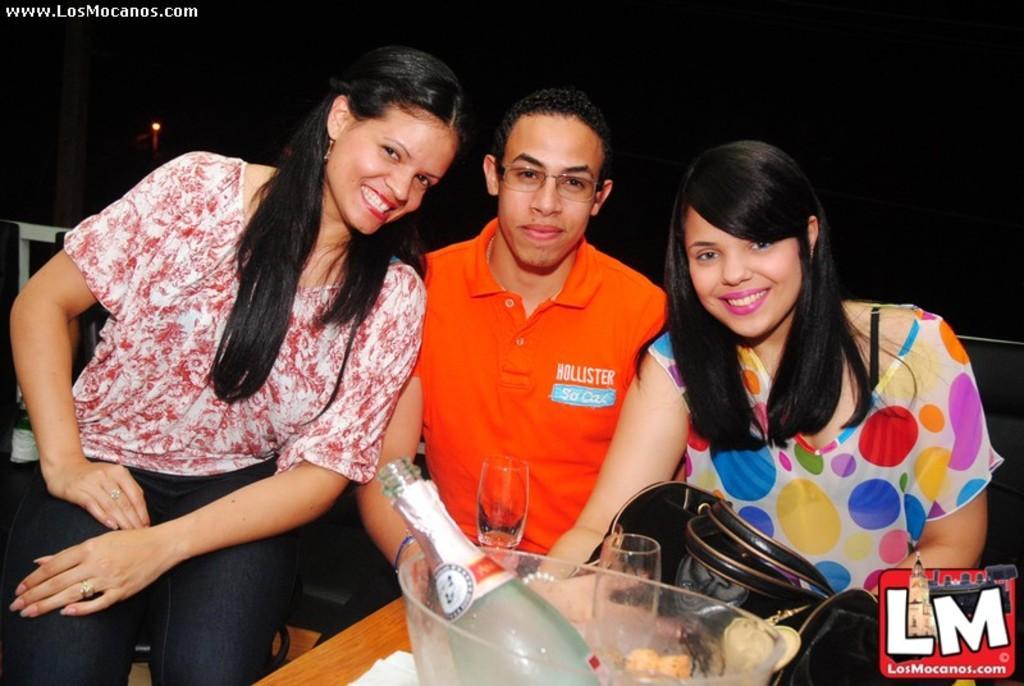Could you give a brief overview of what you see in this image? In this image we can see three persons sitting. In front of the persons we can see few objects. The background of the image is dark. In the top left, we can see the text. In the bottom right we can see an image and text. 